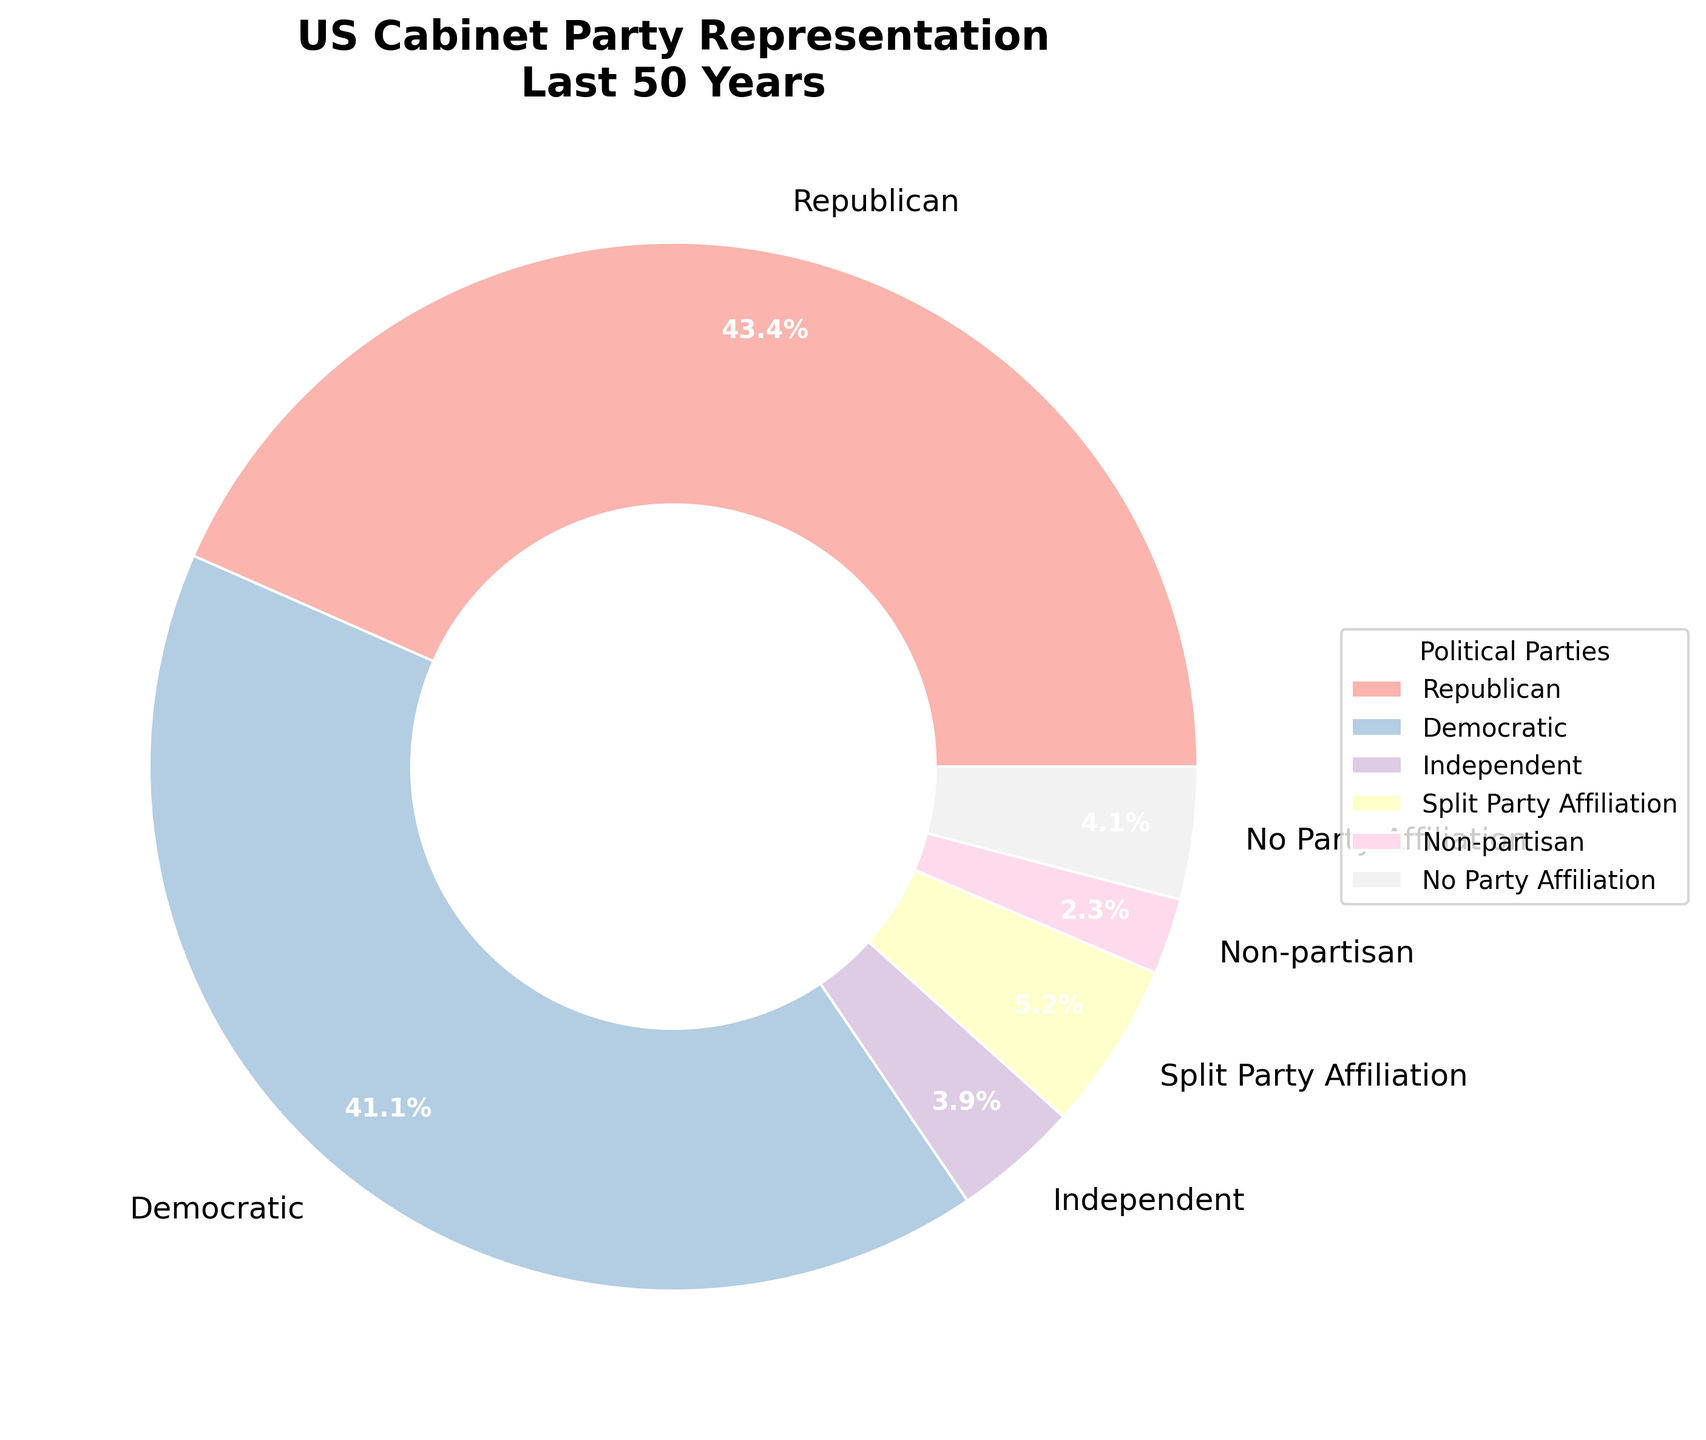Which political party has the highest representation in the US Cabinet over the last 50 years? First, look at the pie chart and identify the party segment with the largest percentage. The largest segment is labeled "Republican" at 42.5%.
Answer: Republican Which two parties have representations close to 40% and can be considered dominant? Look for the portions of the chart labeled closest to 40%. The two largest segments after the Republican segment are "Democratic" at 40.2% and "Republican" at 42.5%.
Answer: Democratic and Republican What percentage of the US Cabinet members belonged to parties other than the Democratic or Republican parties over the last 50 years? Sum up the percentages of all parties other than Democratic and Republican. The sum is 3.8 + 5.1 + 2.3 + 0.7 + 0.4 + 0.2 + 0.5 + 0.3 + 4.0 = 17.3%.
Answer: 17.3% How does the representation of Independents compare to that of those with No Party Affiliation? Compare the percentages for "Independent" (3.8%) and "No Party Affiliation" (4.0%).
Answer: No Party Affiliation is higher by 0.2% Which party representations are less than 1%? Identify the segments in the pie chart with percentages less than 1%. The parties are "Libertarian" (0.7%), "Green Party" (0.4%), "Constitution Party" (0.2%), "Reform Party" (0.5%), and "American Independent Party" (0.3%).
Answer: Libertarian, Green Party, Constitution Party, Reform Party, American Independent Party What is the total percentage of representation for parties with less than 1%? Add the percentages of all the parties with less than 1%. The sum is 0.7 + 0.4 + 0.2 + 0.5 + 0.3 = 2.1%.
Answer: 2.1% How does the representation of those with Split Party Affiliation compare to Non-partisan members? Compare the percentages for "Split Party Affiliation" (5.1%) and "Non-partisan" (2.3%).
Answer: Split Party Affiliation is higher by 2.8% What is the combined percentage of Republican and Democratic representation in the US Cabinet? Add the percentages of the "Republican" and "Democratic" parties. The sum is 42.5 + 40.2 = 82.7%.
Answer: 82.7% 